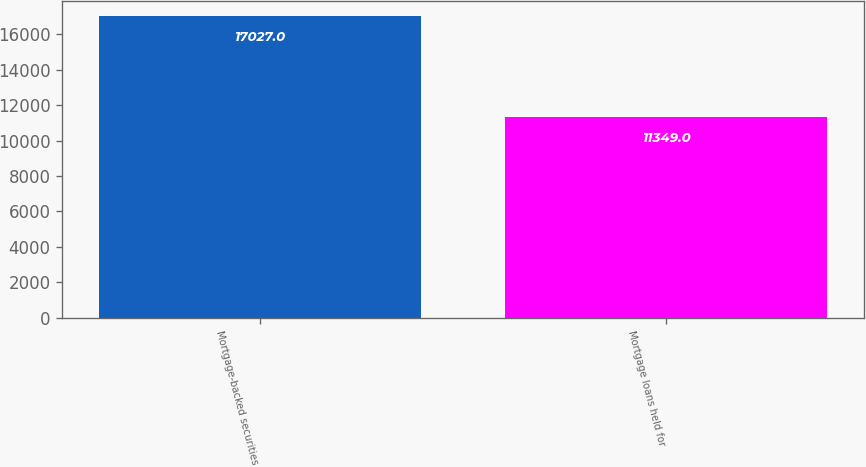Convert chart to OTSL. <chart><loc_0><loc_0><loc_500><loc_500><bar_chart><fcel>Mortgage-backed securities<fcel>Mortgage loans held for<nl><fcel>17027<fcel>11349<nl></chart> 